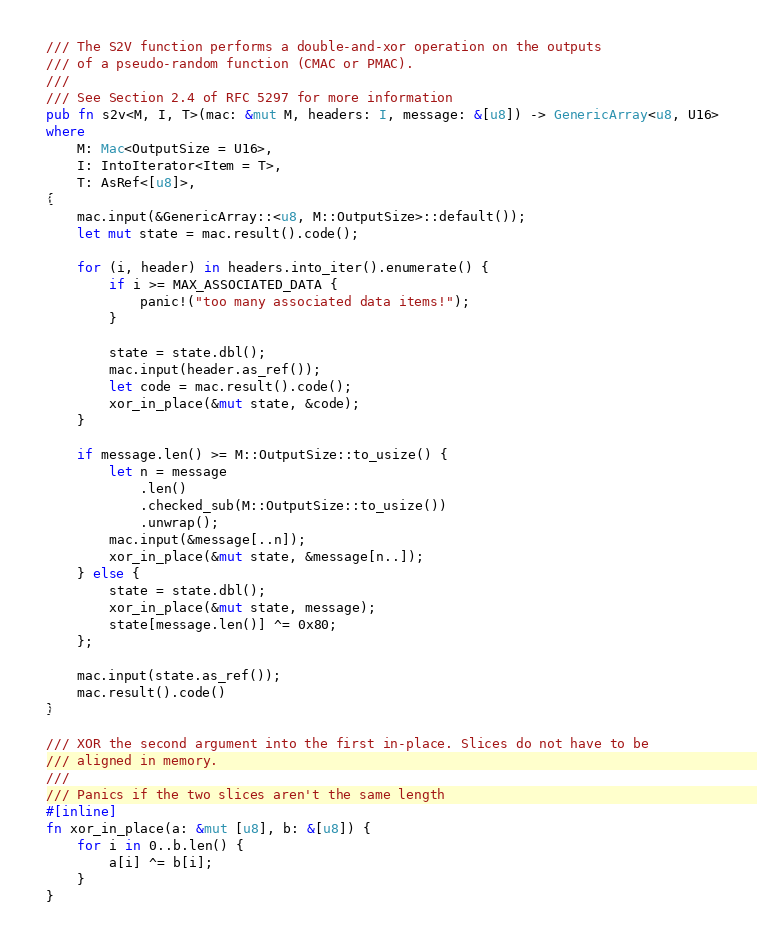<code> <loc_0><loc_0><loc_500><loc_500><_Rust_>/// The S2V function performs a double-and-xor operation on the outputs
/// of a pseudo-random function (CMAC or PMAC).
///
/// See Section 2.4 of RFC 5297 for more information
pub fn s2v<M, I, T>(mac: &mut M, headers: I, message: &[u8]) -> GenericArray<u8, U16>
where
    M: Mac<OutputSize = U16>,
    I: IntoIterator<Item = T>,
    T: AsRef<[u8]>,
{
    mac.input(&GenericArray::<u8, M::OutputSize>::default());
    let mut state = mac.result().code();

    for (i, header) in headers.into_iter().enumerate() {
        if i >= MAX_ASSOCIATED_DATA {
            panic!("too many associated data items!");
        }

        state = state.dbl();
        mac.input(header.as_ref());
        let code = mac.result().code();
        xor_in_place(&mut state, &code);
    }

    if message.len() >= M::OutputSize::to_usize() {
        let n = message
            .len()
            .checked_sub(M::OutputSize::to_usize())
            .unwrap();
        mac.input(&message[..n]);
        xor_in_place(&mut state, &message[n..]);
    } else {
        state = state.dbl();
        xor_in_place(&mut state, message);
        state[message.len()] ^= 0x80;
    };

    mac.input(state.as_ref());
    mac.result().code()
}

/// XOR the second argument into the first in-place. Slices do not have to be
/// aligned in memory.
///
/// Panics if the two slices aren't the same length
#[inline]
fn xor_in_place(a: &mut [u8], b: &[u8]) {
    for i in 0..b.len() {
        a[i] ^= b[i];
    }
}
</code> 